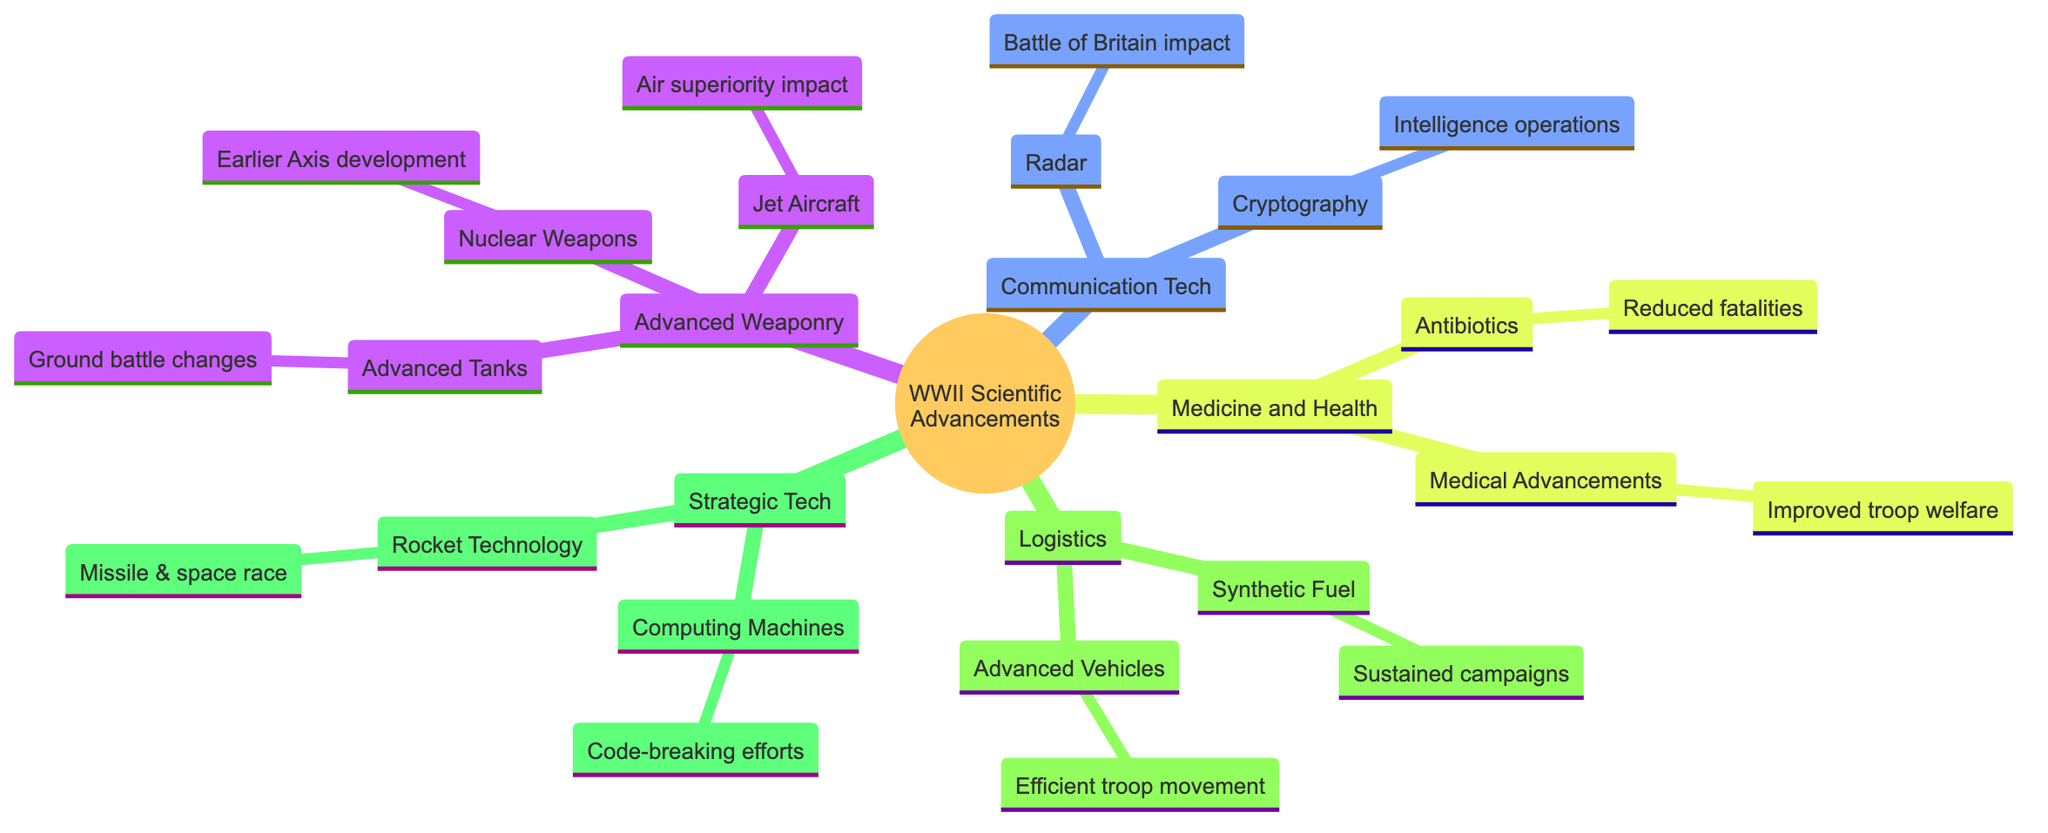What are the two main categories of advancements listed in the diagram? The diagram displays several categories, but the two primary ones are 'Advanced Weaponry' and 'Communication Technology'. By observing the first level of nodes directly connected to the main topic, these categories are readily identifiable.
Answer: Advanced Weaponry, Communication Technology How many elements are under 'Medicine and Health'? 'Medicine and Health' contains two elements, which are 'Antibiotics' and 'Medical Advancements'. Counting the immediate sub-nodes under this category provides the total.
Answer: 2 What technology had implications on the Battle of Britain? The diagram highlights 'Radar' as the technology that had significant implications for the Battle of Britain, indicated under the 'Communication Technology' category.
Answer: Radar Which advancement is associated with reducing soldier fatalities? 'Antibiotics' is associated with the reduction of soldier fatalities in the 'Medicine and Health' section, where its description specifically mentions its impact on soldier health.
Answer: Antibiotics How does 'Synthetic Fuel' affect Axis powers during WWII? 'Synthetic Fuel' is represented as having a direct impact on the Axis powers' ability to sustain prolonged campaigns. By looking at the relationship between 'Synthetic Fuel' and its description under 'Logistics and Transportation', the reasoning is established.
Answer: Prolonged campaigns What are the implications of advancements in rocket technology stated in the diagram? The diagram indicates that advancements in rocket technology influence both missile attacks and have implications for the space race in the post-war scenario. This is derived from the description linked to 'Rocket Technology' under 'Strategic Technologies'.
Answer: Missile attacks and space race Which advanced technology is linked to code-breaking efforts in WWII? The diagram names 'Computing Machines' as the advancement linked to code-breaking efforts, directly mentioned in the 'Strategic Technologies' section. This connection can be traced by looking at the elements categorized under this topic.
Answer: Computing Machines Name one example of advanced weaponry mentioned in the diagram. One example of advanced weaponry from the diagram is 'Nuclear Weapons', which is listed under the 'Advanced Weaponry' category.
Answer: Nuclear Weapons 